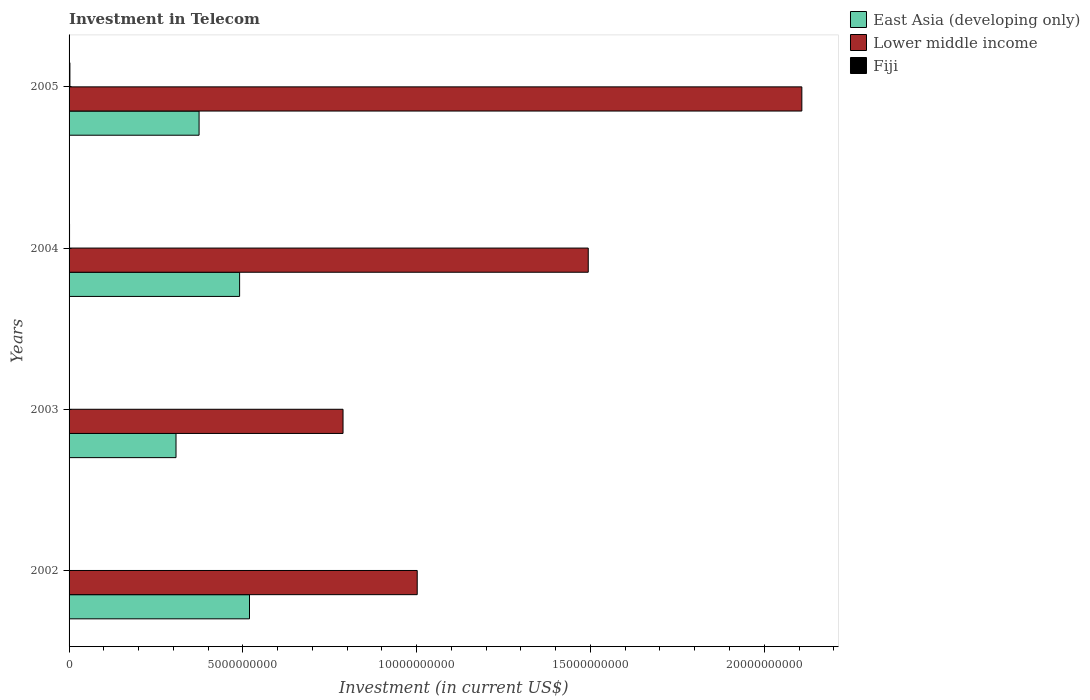How many different coloured bars are there?
Give a very brief answer. 3. How many groups of bars are there?
Provide a short and direct response. 4. How many bars are there on the 3rd tick from the bottom?
Your response must be concise. 3. In how many cases, is the number of bars for a given year not equal to the number of legend labels?
Keep it short and to the point. 0. What is the amount invested in telecom in East Asia (developing only) in 2002?
Offer a terse response. 5.19e+09. Across all years, what is the maximum amount invested in telecom in Lower middle income?
Provide a short and direct response. 2.11e+1. Across all years, what is the minimum amount invested in telecom in Lower middle income?
Your answer should be very brief. 7.88e+09. In which year was the amount invested in telecom in East Asia (developing only) maximum?
Your answer should be compact. 2002. What is the total amount invested in telecom in Fiji in the graph?
Keep it short and to the point. 4.37e+07. What is the difference between the amount invested in telecom in Fiji in 2002 and that in 2005?
Make the answer very short. -2.11e+07. What is the difference between the amount invested in telecom in East Asia (developing only) in 2004 and the amount invested in telecom in Fiji in 2005?
Your answer should be compact. 4.88e+09. What is the average amount invested in telecom in East Asia (developing only) per year?
Give a very brief answer. 4.23e+09. In the year 2002, what is the difference between the amount invested in telecom in Lower middle income and amount invested in telecom in Fiji?
Keep it short and to the point. 1.00e+1. What is the ratio of the amount invested in telecom in East Asia (developing only) in 2002 to that in 2003?
Your answer should be very brief. 1.69. Is the amount invested in telecom in East Asia (developing only) in 2002 less than that in 2005?
Your answer should be very brief. No. Is the difference between the amount invested in telecom in Lower middle income in 2002 and 2004 greater than the difference between the amount invested in telecom in Fiji in 2002 and 2004?
Your response must be concise. No. What is the difference between the highest and the second highest amount invested in telecom in Fiji?
Offer a very short reply. 1.01e+07. What is the difference between the highest and the lowest amount invested in telecom in East Asia (developing only)?
Offer a terse response. 2.11e+09. Is the sum of the amount invested in telecom in Fiji in 2002 and 2005 greater than the maximum amount invested in telecom in East Asia (developing only) across all years?
Give a very brief answer. No. What does the 1st bar from the top in 2005 represents?
Make the answer very short. Fiji. What does the 2nd bar from the bottom in 2005 represents?
Offer a very short reply. Lower middle income. Is it the case that in every year, the sum of the amount invested in telecom in East Asia (developing only) and amount invested in telecom in Lower middle income is greater than the amount invested in telecom in Fiji?
Your response must be concise. Yes. How many bars are there?
Give a very brief answer. 12. Does the graph contain any zero values?
Offer a terse response. No. How are the legend labels stacked?
Provide a short and direct response. Vertical. What is the title of the graph?
Offer a terse response. Investment in Telecom. What is the label or title of the X-axis?
Give a very brief answer. Investment (in current US$). What is the Investment (in current US$) in East Asia (developing only) in 2002?
Ensure brevity in your answer.  5.19e+09. What is the Investment (in current US$) in Lower middle income in 2002?
Offer a terse response. 1.00e+1. What is the Investment (in current US$) in Fiji in 2002?
Offer a very short reply. 2.90e+06. What is the Investment (in current US$) in East Asia (developing only) in 2003?
Your response must be concise. 3.08e+09. What is the Investment (in current US$) in Lower middle income in 2003?
Offer a terse response. 7.88e+09. What is the Investment (in current US$) in Fiji in 2003?
Your response must be concise. 2.90e+06. What is the Investment (in current US$) in East Asia (developing only) in 2004?
Your answer should be very brief. 4.91e+09. What is the Investment (in current US$) of Lower middle income in 2004?
Offer a terse response. 1.49e+1. What is the Investment (in current US$) of Fiji in 2004?
Offer a very short reply. 1.39e+07. What is the Investment (in current US$) of East Asia (developing only) in 2005?
Provide a succinct answer. 3.74e+09. What is the Investment (in current US$) of Lower middle income in 2005?
Your answer should be compact. 2.11e+1. What is the Investment (in current US$) of Fiji in 2005?
Keep it short and to the point. 2.40e+07. Across all years, what is the maximum Investment (in current US$) in East Asia (developing only)?
Your answer should be very brief. 5.19e+09. Across all years, what is the maximum Investment (in current US$) of Lower middle income?
Offer a very short reply. 2.11e+1. Across all years, what is the maximum Investment (in current US$) of Fiji?
Offer a very short reply. 2.40e+07. Across all years, what is the minimum Investment (in current US$) of East Asia (developing only)?
Give a very brief answer. 3.08e+09. Across all years, what is the minimum Investment (in current US$) in Lower middle income?
Ensure brevity in your answer.  7.88e+09. Across all years, what is the minimum Investment (in current US$) of Fiji?
Your answer should be compact. 2.90e+06. What is the total Investment (in current US$) in East Asia (developing only) in the graph?
Offer a very short reply. 1.69e+1. What is the total Investment (in current US$) in Lower middle income in the graph?
Your answer should be very brief. 5.39e+1. What is the total Investment (in current US$) of Fiji in the graph?
Offer a very short reply. 4.37e+07. What is the difference between the Investment (in current US$) of East Asia (developing only) in 2002 and that in 2003?
Provide a short and direct response. 2.11e+09. What is the difference between the Investment (in current US$) of Lower middle income in 2002 and that in 2003?
Your answer should be compact. 2.13e+09. What is the difference between the Investment (in current US$) in East Asia (developing only) in 2002 and that in 2004?
Your answer should be compact. 2.84e+08. What is the difference between the Investment (in current US$) of Lower middle income in 2002 and that in 2004?
Your response must be concise. -4.92e+09. What is the difference between the Investment (in current US$) of Fiji in 2002 and that in 2004?
Offer a very short reply. -1.10e+07. What is the difference between the Investment (in current US$) of East Asia (developing only) in 2002 and that in 2005?
Keep it short and to the point. 1.45e+09. What is the difference between the Investment (in current US$) of Lower middle income in 2002 and that in 2005?
Ensure brevity in your answer.  -1.11e+1. What is the difference between the Investment (in current US$) in Fiji in 2002 and that in 2005?
Keep it short and to the point. -2.11e+07. What is the difference between the Investment (in current US$) in East Asia (developing only) in 2003 and that in 2004?
Give a very brief answer. -1.83e+09. What is the difference between the Investment (in current US$) of Lower middle income in 2003 and that in 2004?
Provide a succinct answer. -7.05e+09. What is the difference between the Investment (in current US$) in Fiji in 2003 and that in 2004?
Make the answer very short. -1.10e+07. What is the difference between the Investment (in current US$) of East Asia (developing only) in 2003 and that in 2005?
Give a very brief answer. -6.63e+08. What is the difference between the Investment (in current US$) in Lower middle income in 2003 and that in 2005?
Your answer should be compact. -1.32e+1. What is the difference between the Investment (in current US$) of Fiji in 2003 and that in 2005?
Offer a terse response. -2.11e+07. What is the difference between the Investment (in current US$) in East Asia (developing only) in 2004 and that in 2005?
Your answer should be compact. 1.17e+09. What is the difference between the Investment (in current US$) of Lower middle income in 2004 and that in 2005?
Provide a succinct answer. -6.14e+09. What is the difference between the Investment (in current US$) of Fiji in 2004 and that in 2005?
Make the answer very short. -1.01e+07. What is the difference between the Investment (in current US$) in East Asia (developing only) in 2002 and the Investment (in current US$) in Lower middle income in 2003?
Provide a short and direct response. -2.69e+09. What is the difference between the Investment (in current US$) in East Asia (developing only) in 2002 and the Investment (in current US$) in Fiji in 2003?
Offer a terse response. 5.19e+09. What is the difference between the Investment (in current US$) of Lower middle income in 2002 and the Investment (in current US$) of Fiji in 2003?
Provide a succinct answer. 1.00e+1. What is the difference between the Investment (in current US$) in East Asia (developing only) in 2002 and the Investment (in current US$) in Lower middle income in 2004?
Offer a terse response. -9.75e+09. What is the difference between the Investment (in current US$) of East Asia (developing only) in 2002 and the Investment (in current US$) of Fiji in 2004?
Keep it short and to the point. 5.18e+09. What is the difference between the Investment (in current US$) of Lower middle income in 2002 and the Investment (in current US$) of Fiji in 2004?
Ensure brevity in your answer.  1.00e+1. What is the difference between the Investment (in current US$) of East Asia (developing only) in 2002 and the Investment (in current US$) of Lower middle income in 2005?
Provide a short and direct response. -1.59e+1. What is the difference between the Investment (in current US$) of East Asia (developing only) in 2002 and the Investment (in current US$) of Fiji in 2005?
Give a very brief answer. 5.17e+09. What is the difference between the Investment (in current US$) in Lower middle income in 2002 and the Investment (in current US$) in Fiji in 2005?
Provide a short and direct response. 9.99e+09. What is the difference between the Investment (in current US$) of East Asia (developing only) in 2003 and the Investment (in current US$) of Lower middle income in 2004?
Ensure brevity in your answer.  -1.19e+1. What is the difference between the Investment (in current US$) in East Asia (developing only) in 2003 and the Investment (in current US$) in Fiji in 2004?
Your answer should be compact. 3.06e+09. What is the difference between the Investment (in current US$) in Lower middle income in 2003 and the Investment (in current US$) in Fiji in 2004?
Give a very brief answer. 7.87e+09. What is the difference between the Investment (in current US$) in East Asia (developing only) in 2003 and the Investment (in current US$) in Lower middle income in 2005?
Offer a terse response. -1.80e+1. What is the difference between the Investment (in current US$) of East Asia (developing only) in 2003 and the Investment (in current US$) of Fiji in 2005?
Make the answer very short. 3.05e+09. What is the difference between the Investment (in current US$) in Lower middle income in 2003 and the Investment (in current US$) in Fiji in 2005?
Provide a short and direct response. 7.86e+09. What is the difference between the Investment (in current US$) in East Asia (developing only) in 2004 and the Investment (in current US$) in Lower middle income in 2005?
Make the answer very short. -1.62e+1. What is the difference between the Investment (in current US$) of East Asia (developing only) in 2004 and the Investment (in current US$) of Fiji in 2005?
Your response must be concise. 4.88e+09. What is the difference between the Investment (in current US$) of Lower middle income in 2004 and the Investment (in current US$) of Fiji in 2005?
Give a very brief answer. 1.49e+1. What is the average Investment (in current US$) of East Asia (developing only) per year?
Your response must be concise. 4.23e+09. What is the average Investment (in current US$) of Lower middle income per year?
Your response must be concise. 1.35e+1. What is the average Investment (in current US$) of Fiji per year?
Ensure brevity in your answer.  1.09e+07. In the year 2002, what is the difference between the Investment (in current US$) in East Asia (developing only) and Investment (in current US$) in Lower middle income?
Give a very brief answer. -4.83e+09. In the year 2002, what is the difference between the Investment (in current US$) of East Asia (developing only) and Investment (in current US$) of Fiji?
Your answer should be compact. 5.19e+09. In the year 2002, what is the difference between the Investment (in current US$) of Lower middle income and Investment (in current US$) of Fiji?
Provide a short and direct response. 1.00e+1. In the year 2003, what is the difference between the Investment (in current US$) in East Asia (developing only) and Investment (in current US$) in Lower middle income?
Offer a very short reply. -4.80e+09. In the year 2003, what is the difference between the Investment (in current US$) of East Asia (developing only) and Investment (in current US$) of Fiji?
Your response must be concise. 3.07e+09. In the year 2003, what is the difference between the Investment (in current US$) in Lower middle income and Investment (in current US$) in Fiji?
Give a very brief answer. 7.88e+09. In the year 2004, what is the difference between the Investment (in current US$) in East Asia (developing only) and Investment (in current US$) in Lower middle income?
Provide a succinct answer. -1.00e+1. In the year 2004, what is the difference between the Investment (in current US$) in East Asia (developing only) and Investment (in current US$) in Fiji?
Give a very brief answer. 4.89e+09. In the year 2004, what is the difference between the Investment (in current US$) of Lower middle income and Investment (in current US$) of Fiji?
Your response must be concise. 1.49e+1. In the year 2005, what is the difference between the Investment (in current US$) in East Asia (developing only) and Investment (in current US$) in Lower middle income?
Your answer should be compact. -1.73e+1. In the year 2005, what is the difference between the Investment (in current US$) in East Asia (developing only) and Investment (in current US$) in Fiji?
Your response must be concise. 3.72e+09. In the year 2005, what is the difference between the Investment (in current US$) in Lower middle income and Investment (in current US$) in Fiji?
Ensure brevity in your answer.  2.11e+1. What is the ratio of the Investment (in current US$) in East Asia (developing only) in 2002 to that in 2003?
Ensure brevity in your answer.  1.69. What is the ratio of the Investment (in current US$) in Lower middle income in 2002 to that in 2003?
Your response must be concise. 1.27. What is the ratio of the Investment (in current US$) in East Asia (developing only) in 2002 to that in 2004?
Your answer should be very brief. 1.06. What is the ratio of the Investment (in current US$) in Lower middle income in 2002 to that in 2004?
Your answer should be very brief. 0.67. What is the ratio of the Investment (in current US$) of Fiji in 2002 to that in 2004?
Give a very brief answer. 0.21. What is the ratio of the Investment (in current US$) in East Asia (developing only) in 2002 to that in 2005?
Keep it short and to the point. 1.39. What is the ratio of the Investment (in current US$) in Lower middle income in 2002 to that in 2005?
Your answer should be very brief. 0.48. What is the ratio of the Investment (in current US$) in Fiji in 2002 to that in 2005?
Make the answer very short. 0.12. What is the ratio of the Investment (in current US$) of East Asia (developing only) in 2003 to that in 2004?
Your answer should be compact. 0.63. What is the ratio of the Investment (in current US$) in Lower middle income in 2003 to that in 2004?
Keep it short and to the point. 0.53. What is the ratio of the Investment (in current US$) of Fiji in 2003 to that in 2004?
Keep it short and to the point. 0.21. What is the ratio of the Investment (in current US$) of East Asia (developing only) in 2003 to that in 2005?
Ensure brevity in your answer.  0.82. What is the ratio of the Investment (in current US$) in Lower middle income in 2003 to that in 2005?
Provide a short and direct response. 0.37. What is the ratio of the Investment (in current US$) in Fiji in 2003 to that in 2005?
Your answer should be compact. 0.12. What is the ratio of the Investment (in current US$) of East Asia (developing only) in 2004 to that in 2005?
Your answer should be compact. 1.31. What is the ratio of the Investment (in current US$) of Lower middle income in 2004 to that in 2005?
Provide a short and direct response. 0.71. What is the ratio of the Investment (in current US$) of Fiji in 2004 to that in 2005?
Offer a terse response. 0.58. What is the difference between the highest and the second highest Investment (in current US$) of East Asia (developing only)?
Provide a short and direct response. 2.84e+08. What is the difference between the highest and the second highest Investment (in current US$) in Lower middle income?
Offer a very short reply. 6.14e+09. What is the difference between the highest and the second highest Investment (in current US$) of Fiji?
Provide a short and direct response. 1.01e+07. What is the difference between the highest and the lowest Investment (in current US$) of East Asia (developing only)?
Ensure brevity in your answer.  2.11e+09. What is the difference between the highest and the lowest Investment (in current US$) of Lower middle income?
Keep it short and to the point. 1.32e+1. What is the difference between the highest and the lowest Investment (in current US$) of Fiji?
Give a very brief answer. 2.11e+07. 